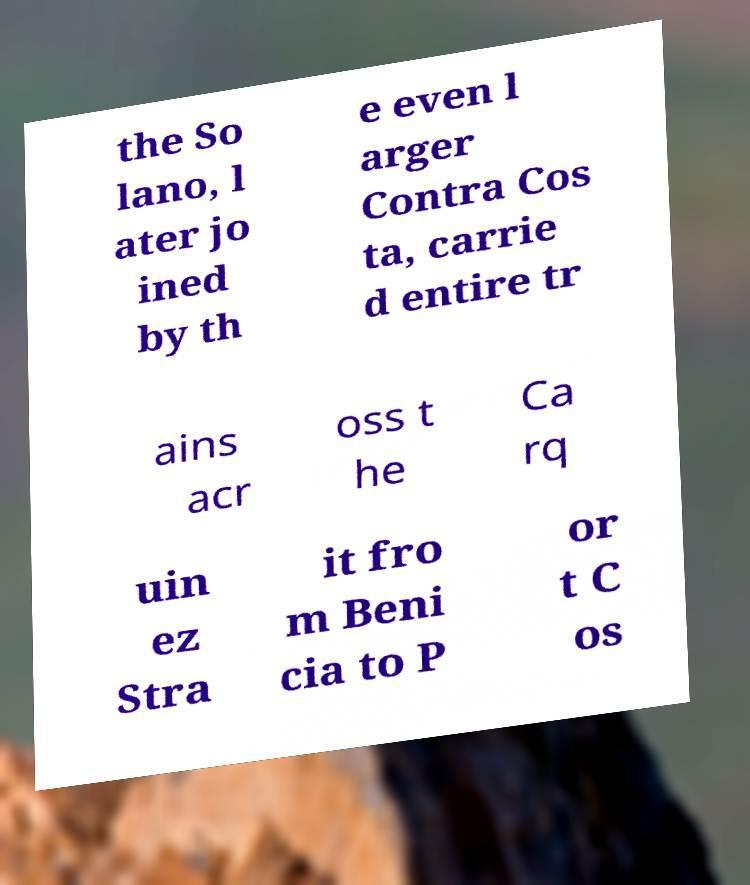Can you read and provide the text displayed in the image?This photo seems to have some interesting text. Can you extract and type it out for me? the So lano, l ater jo ined by th e even l arger Contra Cos ta, carrie d entire tr ains acr oss t he Ca rq uin ez Stra it fro m Beni cia to P or t C os 